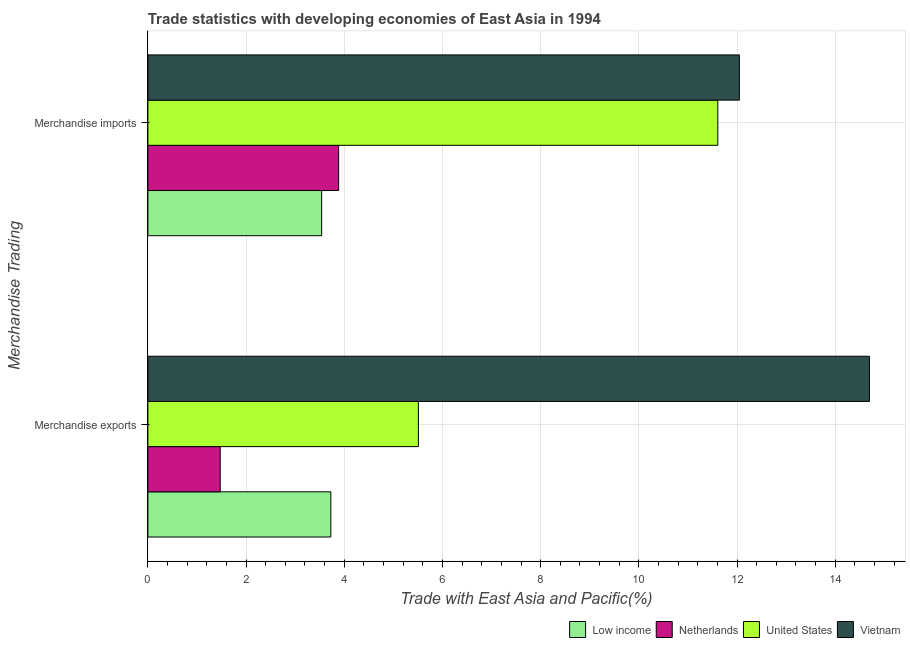How many groups of bars are there?
Provide a succinct answer. 2. Are the number of bars on each tick of the Y-axis equal?
Your answer should be very brief. Yes. How many bars are there on the 2nd tick from the top?
Ensure brevity in your answer.  4. What is the merchandise exports in Vietnam?
Your response must be concise. 14.7. Across all countries, what is the maximum merchandise exports?
Your answer should be compact. 14.7. Across all countries, what is the minimum merchandise exports?
Provide a succinct answer. 1.47. In which country was the merchandise exports maximum?
Provide a short and direct response. Vietnam. What is the total merchandise imports in the graph?
Your answer should be very brief. 31.08. What is the difference between the merchandise exports in Netherlands and that in United States?
Your answer should be very brief. -4.04. What is the difference between the merchandise imports in United States and the merchandise exports in Low income?
Offer a very short reply. 7.88. What is the average merchandise exports per country?
Offer a very short reply. 6.35. What is the difference between the merchandise exports and merchandise imports in Low income?
Give a very brief answer. 0.19. In how many countries, is the merchandise imports greater than 14 %?
Offer a very short reply. 0. What is the ratio of the merchandise exports in United States to that in Vietnam?
Ensure brevity in your answer.  0.37. Is the merchandise imports in Vietnam less than that in Low income?
Keep it short and to the point. No. What does the 4th bar from the bottom in Merchandise imports represents?
Give a very brief answer. Vietnam. How many bars are there?
Ensure brevity in your answer.  8. Are all the bars in the graph horizontal?
Offer a very short reply. Yes. Does the graph contain any zero values?
Provide a short and direct response. No. Where does the legend appear in the graph?
Your response must be concise. Bottom right. How are the legend labels stacked?
Ensure brevity in your answer.  Horizontal. What is the title of the graph?
Provide a short and direct response. Trade statistics with developing economies of East Asia in 1994. What is the label or title of the X-axis?
Offer a very short reply. Trade with East Asia and Pacific(%). What is the label or title of the Y-axis?
Your response must be concise. Merchandise Trading. What is the Trade with East Asia and Pacific(%) in Low income in Merchandise exports?
Your answer should be very brief. 3.73. What is the Trade with East Asia and Pacific(%) in Netherlands in Merchandise exports?
Your answer should be compact. 1.47. What is the Trade with East Asia and Pacific(%) in United States in Merchandise exports?
Your answer should be very brief. 5.51. What is the Trade with East Asia and Pacific(%) of Vietnam in Merchandise exports?
Your response must be concise. 14.7. What is the Trade with East Asia and Pacific(%) in Low income in Merchandise imports?
Offer a very short reply. 3.54. What is the Trade with East Asia and Pacific(%) of Netherlands in Merchandise imports?
Make the answer very short. 3.89. What is the Trade with East Asia and Pacific(%) of United States in Merchandise imports?
Give a very brief answer. 11.61. What is the Trade with East Asia and Pacific(%) of Vietnam in Merchandise imports?
Ensure brevity in your answer.  12.05. Across all Merchandise Trading, what is the maximum Trade with East Asia and Pacific(%) in Low income?
Provide a succinct answer. 3.73. Across all Merchandise Trading, what is the maximum Trade with East Asia and Pacific(%) of Netherlands?
Provide a short and direct response. 3.89. Across all Merchandise Trading, what is the maximum Trade with East Asia and Pacific(%) in United States?
Provide a succinct answer. 11.61. Across all Merchandise Trading, what is the maximum Trade with East Asia and Pacific(%) of Vietnam?
Your response must be concise. 14.7. Across all Merchandise Trading, what is the minimum Trade with East Asia and Pacific(%) of Low income?
Your response must be concise. 3.54. Across all Merchandise Trading, what is the minimum Trade with East Asia and Pacific(%) of Netherlands?
Ensure brevity in your answer.  1.47. Across all Merchandise Trading, what is the minimum Trade with East Asia and Pacific(%) of United States?
Provide a short and direct response. 5.51. Across all Merchandise Trading, what is the minimum Trade with East Asia and Pacific(%) in Vietnam?
Ensure brevity in your answer.  12.05. What is the total Trade with East Asia and Pacific(%) in Low income in the graph?
Keep it short and to the point. 7.27. What is the total Trade with East Asia and Pacific(%) of Netherlands in the graph?
Offer a terse response. 5.36. What is the total Trade with East Asia and Pacific(%) of United States in the graph?
Keep it short and to the point. 17.12. What is the total Trade with East Asia and Pacific(%) in Vietnam in the graph?
Provide a short and direct response. 26.74. What is the difference between the Trade with East Asia and Pacific(%) of Low income in Merchandise exports and that in Merchandise imports?
Keep it short and to the point. 0.19. What is the difference between the Trade with East Asia and Pacific(%) in Netherlands in Merchandise exports and that in Merchandise imports?
Your response must be concise. -2.41. What is the difference between the Trade with East Asia and Pacific(%) in United States in Merchandise exports and that in Merchandise imports?
Your response must be concise. -6.1. What is the difference between the Trade with East Asia and Pacific(%) of Vietnam in Merchandise exports and that in Merchandise imports?
Provide a succinct answer. 2.65. What is the difference between the Trade with East Asia and Pacific(%) of Low income in Merchandise exports and the Trade with East Asia and Pacific(%) of Netherlands in Merchandise imports?
Ensure brevity in your answer.  -0.16. What is the difference between the Trade with East Asia and Pacific(%) of Low income in Merchandise exports and the Trade with East Asia and Pacific(%) of United States in Merchandise imports?
Make the answer very short. -7.88. What is the difference between the Trade with East Asia and Pacific(%) of Low income in Merchandise exports and the Trade with East Asia and Pacific(%) of Vietnam in Merchandise imports?
Provide a succinct answer. -8.32. What is the difference between the Trade with East Asia and Pacific(%) of Netherlands in Merchandise exports and the Trade with East Asia and Pacific(%) of United States in Merchandise imports?
Make the answer very short. -10.13. What is the difference between the Trade with East Asia and Pacific(%) in Netherlands in Merchandise exports and the Trade with East Asia and Pacific(%) in Vietnam in Merchandise imports?
Give a very brief answer. -10.57. What is the difference between the Trade with East Asia and Pacific(%) of United States in Merchandise exports and the Trade with East Asia and Pacific(%) of Vietnam in Merchandise imports?
Provide a short and direct response. -6.54. What is the average Trade with East Asia and Pacific(%) of Low income per Merchandise Trading?
Provide a short and direct response. 3.63. What is the average Trade with East Asia and Pacific(%) in Netherlands per Merchandise Trading?
Provide a succinct answer. 2.68. What is the average Trade with East Asia and Pacific(%) of United States per Merchandise Trading?
Ensure brevity in your answer.  8.56. What is the average Trade with East Asia and Pacific(%) in Vietnam per Merchandise Trading?
Your response must be concise. 13.37. What is the difference between the Trade with East Asia and Pacific(%) in Low income and Trade with East Asia and Pacific(%) in Netherlands in Merchandise exports?
Make the answer very short. 2.25. What is the difference between the Trade with East Asia and Pacific(%) in Low income and Trade with East Asia and Pacific(%) in United States in Merchandise exports?
Provide a short and direct response. -1.78. What is the difference between the Trade with East Asia and Pacific(%) in Low income and Trade with East Asia and Pacific(%) in Vietnam in Merchandise exports?
Your answer should be compact. -10.97. What is the difference between the Trade with East Asia and Pacific(%) of Netherlands and Trade with East Asia and Pacific(%) of United States in Merchandise exports?
Your response must be concise. -4.04. What is the difference between the Trade with East Asia and Pacific(%) in Netherlands and Trade with East Asia and Pacific(%) in Vietnam in Merchandise exports?
Your answer should be very brief. -13.22. What is the difference between the Trade with East Asia and Pacific(%) of United States and Trade with East Asia and Pacific(%) of Vietnam in Merchandise exports?
Offer a very short reply. -9.19. What is the difference between the Trade with East Asia and Pacific(%) of Low income and Trade with East Asia and Pacific(%) of Netherlands in Merchandise imports?
Make the answer very short. -0.35. What is the difference between the Trade with East Asia and Pacific(%) in Low income and Trade with East Asia and Pacific(%) in United States in Merchandise imports?
Your response must be concise. -8.07. What is the difference between the Trade with East Asia and Pacific(%) of Low income and Trade with East Asia and Pacific(%) of Vietnam in Merchandise imports?
Your answer should be very brief. -8.51. What is the difference between the Trade with East Asia and Pacific(%) in Netherlands and Trade with East Asia and Pacific(%) in United States in Merchandise imports?
Your answer should be compact. -7.72. What is the difference between the Trade with East Asia and Pacific(%) of Netherlands and Trade with East Asia and Pacific(%) of Vietnam in Merchandise imports?
Offer a very short reply. -8.16. What is the difference between the Trade with East Asia and Pacific(%) in United States and Trade with East Asia and Pacific(%) in Vietnam in Merchandise imports?
Give a very brief answer. -0.44. What is the ratio of the Trade with East Asia and Pacific(%) in Low income in Merchandise exports to that in Merchandise imports?
Give a very brief answer. 1.05. What is the ratio of the Trade with East Asia and Pacific(%) in Netherlands in Merchandise exports to that in Merchandise imports?
Ensure brevity in your answer.  0.38. What is the ratio of the Trade with East Asia and Pacific(%) in United States in Merchandise exports to that in Merchandise imports?
Ensure brevity in your answer.  0.47. What is the ratio of the Trade with East Asia and Pacific(%) of Vietnam in Merchandise exports to that in Merchandise imports?
Your response must be concise. 1.22. What is the difference between the highest and the second highest Trade with East Asia and Pacific(%) of Low income?
Make the answer very short. 0.19. What is the difference between the highest and the second highest Trade with East Asia and Pacific(%) of Netherlands?
Offer a very short reply. 2.41. What is the difference between the highest and the second highest Trade with East Asia and Pacific(%) in United States?
Your answer should be very brief. 6.1. What is the difference between the highest and the second highest Trade with East Asia and Pacific(%) of Vietnam?
Offer a terse response. 2.65. What is the difference between the highest and the lowest Trade with East Asia and Pacific(%) in Low income?
Offer a very short reply. 0.19. What is the difference between the highest and the lowest Trade with East Asia and Pacific(%) of Netherlands?
Ensure brevity in your answer.  2.41. What is the difference between the highest and the lowest Trade with East Asia and Pacific(%) in United States?
Your response must be concise. 6.1. What is the difference between the highest and the lowest Trade with East Asia and Pacific(%) in Vietnam?
Provide a succinct answer. 2.65. 